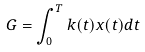Convert formula to latex. <formula><loc_0><loc_0><loc_500><loc_500>G = \int _ { 0 } ^ { T } k ( t ) x ( t ) d t</formula> 